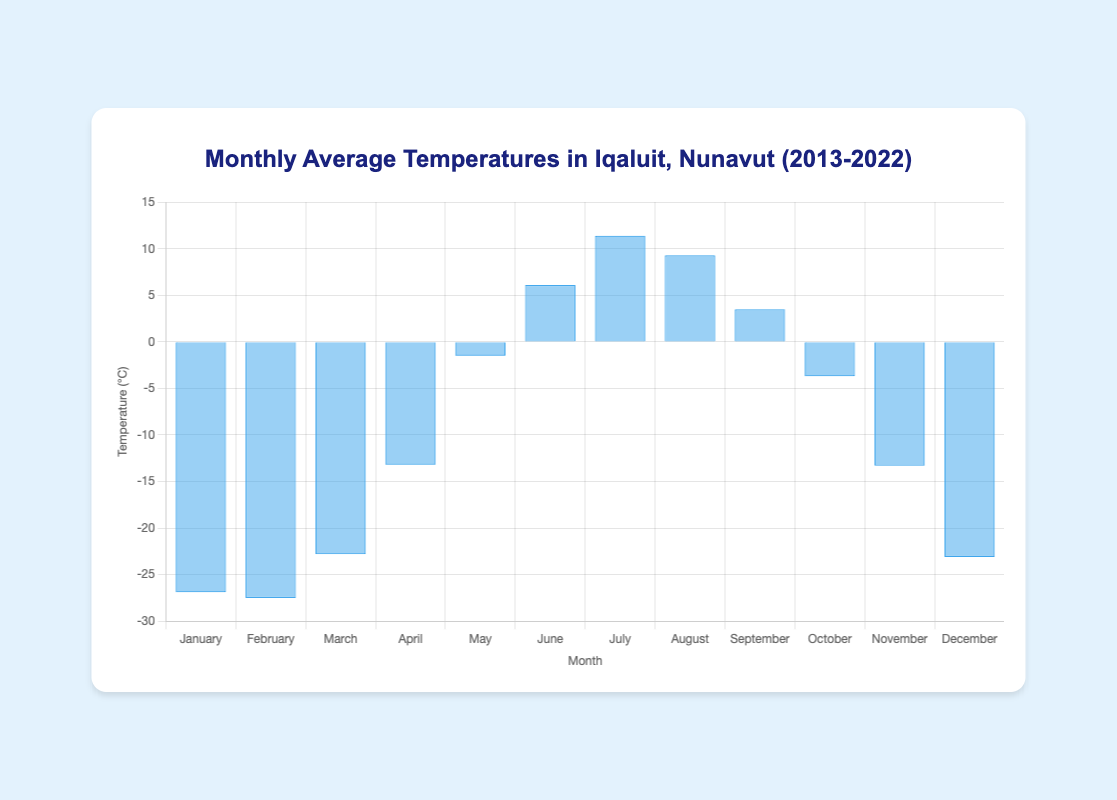What is the average temperature in January? The figure shows the average temperature for each month. For January, the temperature is -26.9°C, indicated with the 🥶 emoji.
Answer: -26.9°C Which month has the highest average temperature? By looking at the bar heights, July has the highest average temperature of 11.4°C, represented by the ☀️ emoji.
Answer: July What is the difference in average temperature between February and April? The figure shows February's average temperature as -27.5°C and April's as -13.2°C. The difference is calculated as -13.2 - (-27.5) = 14.3°C.
Answer: 14.3°C Which months are represented with the 🥶 (frozen face) emoji? The 🥶 emoji is used for the coldest months. January and December have this emoji, with temperatures of -26.9°C and -23.1°C, respectively.
Answer: January and December How many months have an average temperature above 0°C? The figure shows that May, June, July, August, and September have temperatures above 0°C. So, 5 months in total.
Answer: 5 What is the range of the average temperatures shown? The lowest average temperature is -27.5°C in February, and the highest is 11.4°C in July. The range is calculated as 11.4 - (-27.5) = 38.9°C.
Answer: 38.9°C Which month has a higher average temperature, October or November, and by how much? October has an average temperature of -3.7°C and November is -13.3°C. October is warmer by -3.7 - (-13.3) = 9.6°C.
Answer: October by 9.6°C What is the total of the average temperatures for March and September? The figure shows March with -22.8°C and September with 3.5°C. Adding these gives -22.8 + 3.5 = -19.3°C.
Answer: -19.3°C 